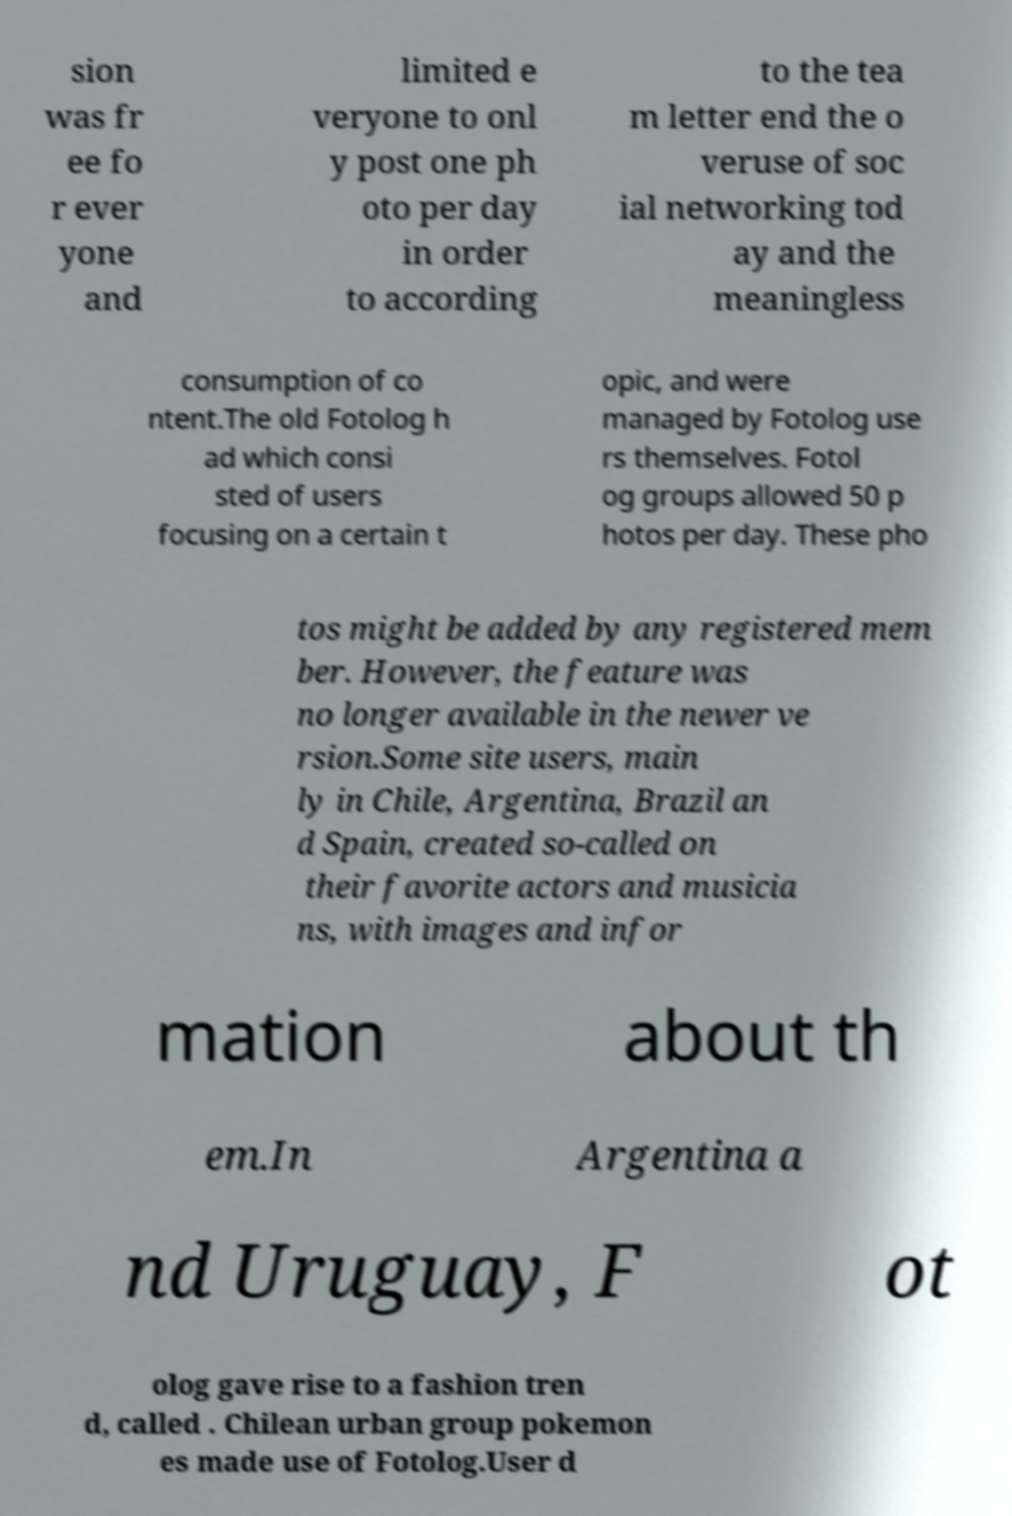Please read and relay the text visible in this image. What does it say? sion was fr ee fo r ever yone and limited e veryone to onl y post one ph oto per day in order to according to the tea m letter end the o veruse of soc ial networking tod ay and the meaningless consumption of co ntent.The old Fotolog h ad which consi sted of users focusing on a certain t opic, and were managed by Fotolog use rs themselves. Fotol og groups allowed 50 p hotos per day. These pho tos might be added by any registered mem ber. However, the feature was no longer available in the newer ve rsion.Some site users, main ly in Chile, Argentina, Brazil an d Spain, created so-called on their favorite actors and musicia ns, with images and infor mation about th em.In Argentina a nd Uruguay, F ot olog gave rise to a fashion tren d, called . Chilean urban group pokemon es made use of Fotolog.User d 